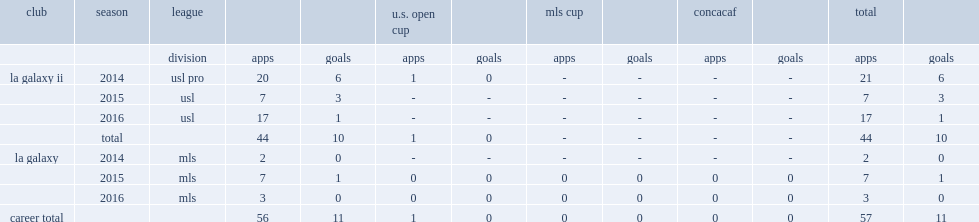Which league did bradford jamieson iv make his debut for la galaxy ii in 2014? Usl pro. 